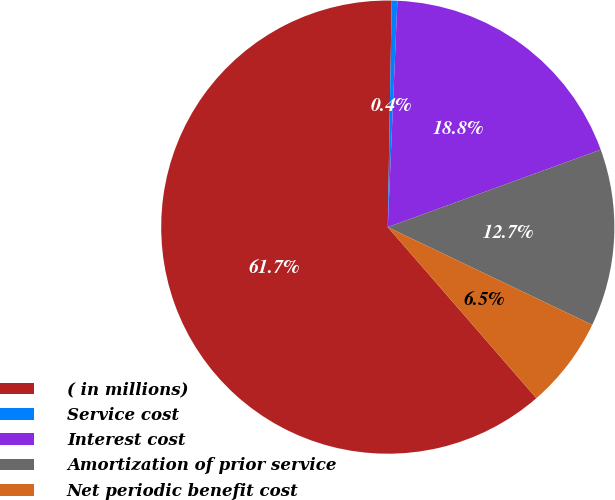<chart> <loc_0><loc_0><loc_500><loc_500><pie_chart><fcel>( in millions)<fcel>Service cost<fcel>Interest cost<fcel>Amortization of prior service<fcel>Net periodic benefit cost<nl><fcel>61.65%<fcel>0.4%<fcel>18.77%<fcel>12.65%<fcel>6.52%<nl></chart> 